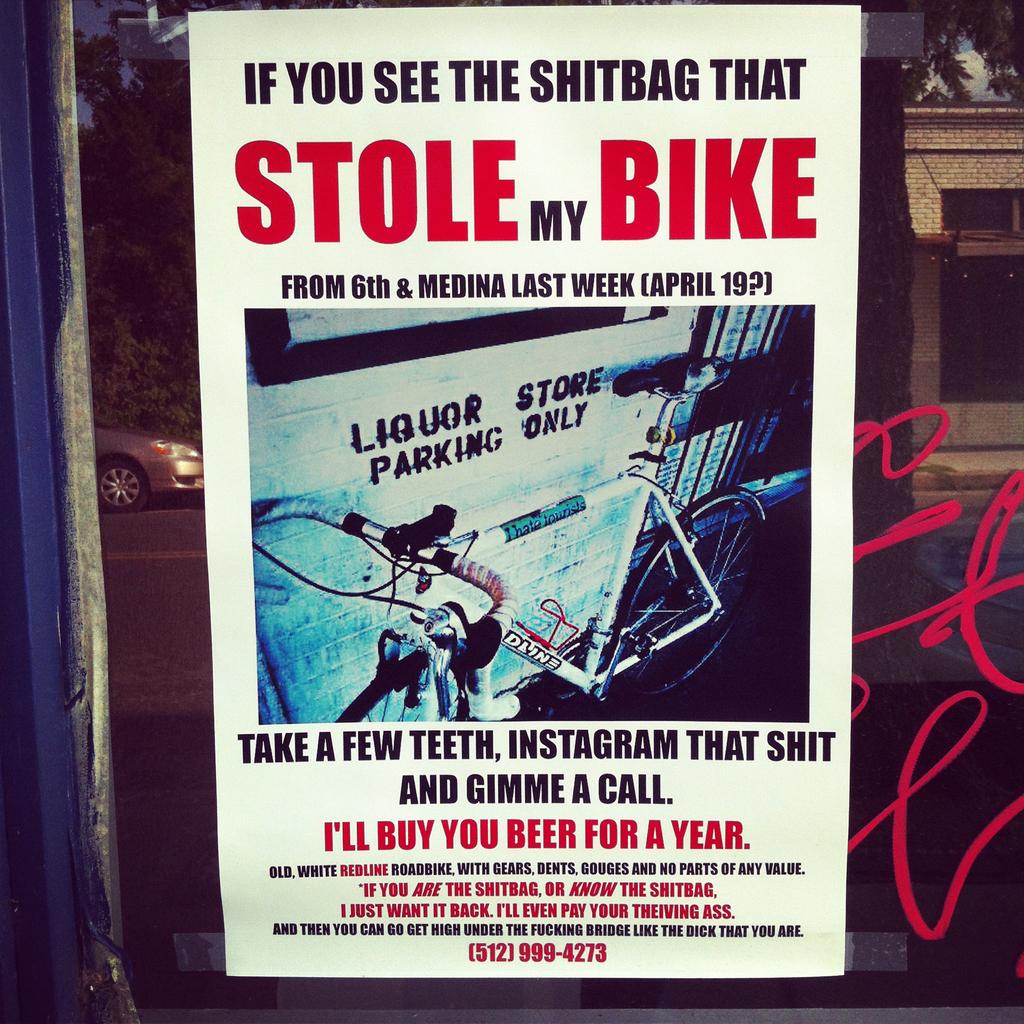What was stolen?
Offer a very short reply. Bike. Who is the parking for?
Keep it short and to the point. Liquor store. 